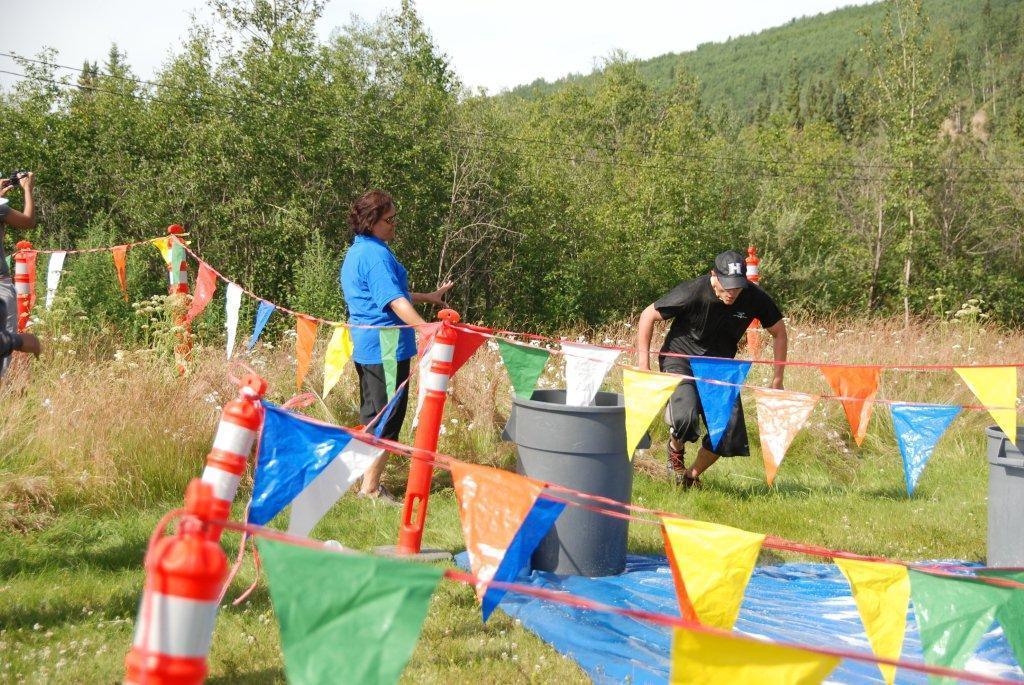Please provide a concise description of this image. In this picture I can see decorative flags on a string. I can see a few people standing on green grass. I can see trees in the background. I can see the hill. I can see clouds in the sky. 